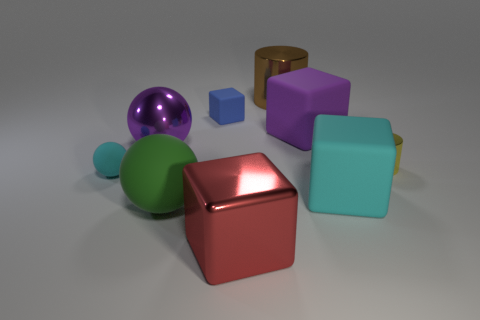Is there any other thing that has the same size as the blue rubber block?
Offer a terse response. Yes. Are there more cyan rubber spheres that are on the right side of the blue matte block than large shiny cylinders that are to the left of the red metallic block?
Make the answer very short. No. There is a tiny rubber object in front of the cylinder that is in front of the thing behind the tiny blue block; what color is it?
Give a very brief answer. Cyan. There is a metal cylinder in front of the small matte block; is its color the same as the large metallic cylinder?
Keep it short and to the point. No. What number of other things are the same color as the big matte ball?
Your answer should be compact. 0. How many things are purple matte cubes or large rubber balls?
Your answer should be compact. 2. How many things are purple matte blocks or large rubber things in front of the tiny yellow object?
Offer a very short reply. 3. Are the yellow thing and the large green ball made of the same material?
Make the answer very short. No. What number of other things are there of the same material as the large purple ball
Make the answer very short. 3. Are there more small balls than small gray rubber balls?
Your response must be concise. Yes. 